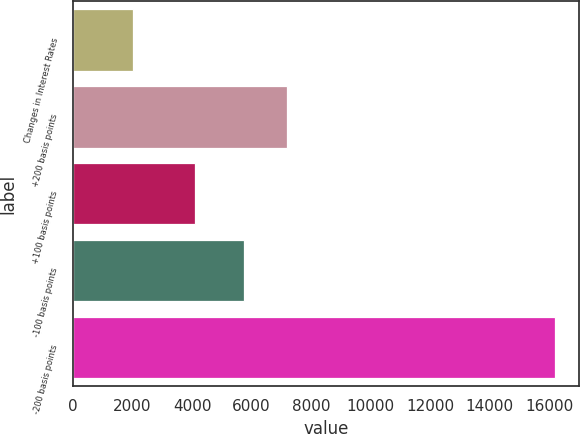<chart> <loc_0><loc_0><loc_500><loc_500><bar_chart><fcel>Changes in Interest Rates<fcel>+200 basis points<fcel>+100 basis points<fcel>-100 basis points<fcel>-200 basis points<nl><fcel>2005<fcel>7178<fcel>4096<fcel>5733<fcel>16184<nl></chart> 